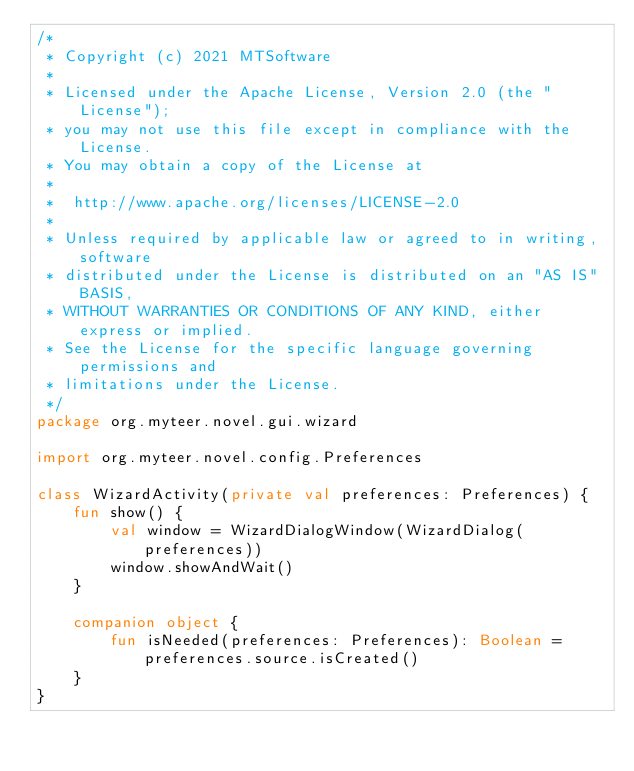<code> <loc_0><loc_0><loc_500><loc_500><_Kotlin_>/*
 * Copyright (c) 2021 MTSoftware
 *
 * Licensed under the Apache License, Version 2.0 (the "License");
 * you may not use this file except in compliance with the License.
 * You may obtain a copy of the License at
 *
 *  http://www.apache.org/licenses/LICENSE-2.0
 *
 * Unless required by applicable law or agreed to in writing, software
 * distributed under the License is distributed on an "AS IS" BASIS,
 * WITHOUT WARRANTIES OR CONDITIONS OF ANY KIND, either express or implied.
 * See the License for the specific language governing permissions and
 * limitations under the License.
 */
package org.myteer.novel.gui.wizard

import org.myteer.novel.config.Preferences

class WizardActivity(private val preferences: Preferences) {
    fun show() {
        val window = WizardDialogWindow(WizardDialog(preferences))
        window.showAndWait()
    }

    companion object {
        fun isNeeded(preferences: Preferences): Boolean = preferences.source.isCreated()
    }
}</code> 